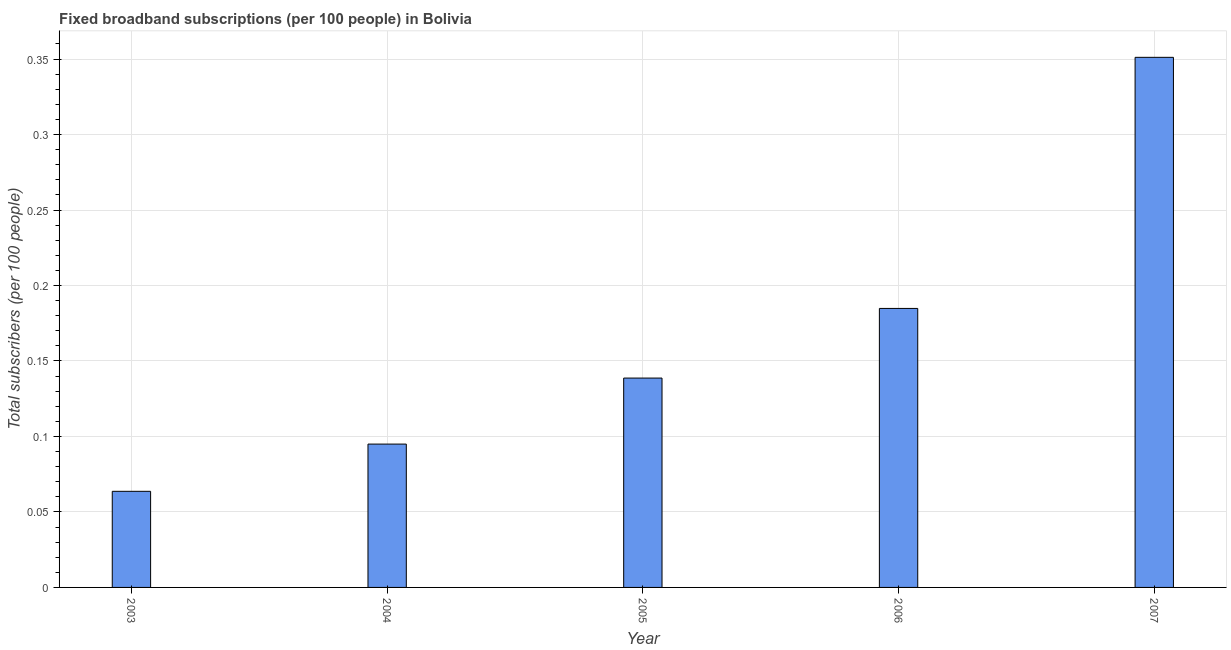Does the graph contain any zero values?
Offer a very short reply. No. Does the graph contain grids?
Offer a very short reply. Yes. What is the title of the graph?
Offer a very short reply. Fixed broadband subscriptions (per 100 people) in Bolivia. What is the label or title of the Y-axis?
Ensure brevity in your answer.  Total subscribers (per 100 people). What is the total number of fixed broadband subscriptions in 2004?
Your answer should be very brief. 0.09. Across all years, what is the maximum total number of fixed broadband subscriptions?
Offer a terse response. 0.35. Across all years, what is the minimum total number of fixed broadband subscriptions?
Provide a succinct answer. 0.06. In which year was the total number of fixed broadband subscriptions maximum?
Offer a very short reply. 2007. In which year was the total number of fixed broadband subscriptions minimum?
Your answer should be compact. 2003. What is the sum of the total number of fixed broadband subscriptions?
Offer a very short reply. 0.83. What is the difference between the total number of fixed broadband subscriptions in 2006 and 2007?
Keep it short and to the point. -0.17. What is the average total number of fixed broadband subscriptions per year?
Offer a terse response. 0.17. What is the median total number of fixed broadband subscriptions?
Ensure brevity in your answer.  0.14. In how many years, is the total number of fixed broadband subscriptions greater than 0.06 ?
Keep it short and to the point. 5. Do a majority of the years between 2003 and 2004 (inclusive) have total number of fixed broadband subscriptions greater than 0.18 ?
Make the answer very short. No. What is the ratio of the total number of fixed broadband subscriptions in 2004 to that in 2006?
Make the answer very short. 0.51. What is the difference between the highest and the second highest total number of fixed broadband subscriptions?
Give a very brief answer. 0.17. Is the sum of the total number of fixed broadband subscriptions in 2003 and 2007 greater than the maximum total number of fixed broadband subscriptions across all years?
Your answer should be very brief. Yes. What is the difference between the highest and the lowest total number of fixed broadband subscriptions?
Give a very brief answer. 0.29. In how many years, is the total number of fixed broadband subscriptions greater than the average total number of fixed broadband subscriptions taken over all years?
Your answer should be very brief. 2. What is the Total subscribers (per 100 people) of 2003?
Ensure brevity in your answer.  0.06. What is the Total subscribers (per 100 people) of 2004?
Give a very brief answer. 0.09. What is the Total subscribers (per 100 people) in 2005?
Keep it short and to the point. 0.14. What is the Total subscribers (per 100 people) in 2006?
Your answer should be compact. 0.18. What is the Total subscribers (per 100 people) in 2007?
Make the answer very short. 0.35. What is the difference between the Total subscribers (per 100 people) in 2003 and 2004?
Provide a short and direct response. -0.03. What is the difference between the Total subscribers (per 100 people) in 2003 and 2005?
Provide a succinct answer. -0.08. What is the difference between the Total subscribers (per 100 people) in 2003 and 2006?
Keep it short and to the point. -0.12. What is the difference between the Total subscribers (per 100 people) in 2003 and 2007?
Your answer should be compact. -0.29. What is the difference between the Total subscribers (per 100 people) in 2004 and 2005?
Make the answer very short. -0.04. What is the difference between the Total subscribers (per 100 people) in 2004 and 2006?
Your answer should be very brief. -0.09. What is the difference between the Total subscribers (per 100 people) in 2004 and 2007?
Your answer should be very brief. -0.26. What is the difference between the Total subscribers (per 100 people) in 2005 and 2006?
Keep it short and to the point. -0.05. What is the difference between the Total subscribers (per 100 people) in 2005 and 2007?
Your response must be concise. -0.21. What is the difference between the Total subscribers (per 100 people) in 2006 and 2007?
Keep it short and to the point. -0.17. What is the ratio of the Total subscribers (per 100 people) in 2003 to that in 2004?
Your answer should be compact. 0.67. What is the ratio of the Total subscribers (per 100 people) in 2003 to that in 2005?
Offer a terse response. 0.46. What is the ratio of the Total subscribers (per 100 people) in 2003 to that in 2006?
Your response must be concise. 0.34. What is the ratio of the Total subscribers (per 100 people) in 2003 to that in 2007?
Provide a succinct answer. 0.18. What is the ratio of the Total subscribers (per 100 people) in 2004 to that in 2005?
Offer a very short reply. 0.69. What is the ratio of the Total subscribers (per 100 people) in 2004 to that in 2006?
Your answer should be compact. 0.51. What is the ratio of the Total subscribers (per 100 people) in 2004 to that in 2007?
Ensure brevity in your answer.  0.27. What is the ratio of the Total subscribers (per 100 people) in 2005 to that in 2006?
Make the answer very short. 0.75. What is the ratio of the Total subscribers (per 100 people) in 2005 to that in 2007?
Ensure brevity in your answer.  0.4. What is the ratio of the Total subscribers (per 100 people) in 2006 to that in 2007?
Provide a short and direct response. 0.53. 